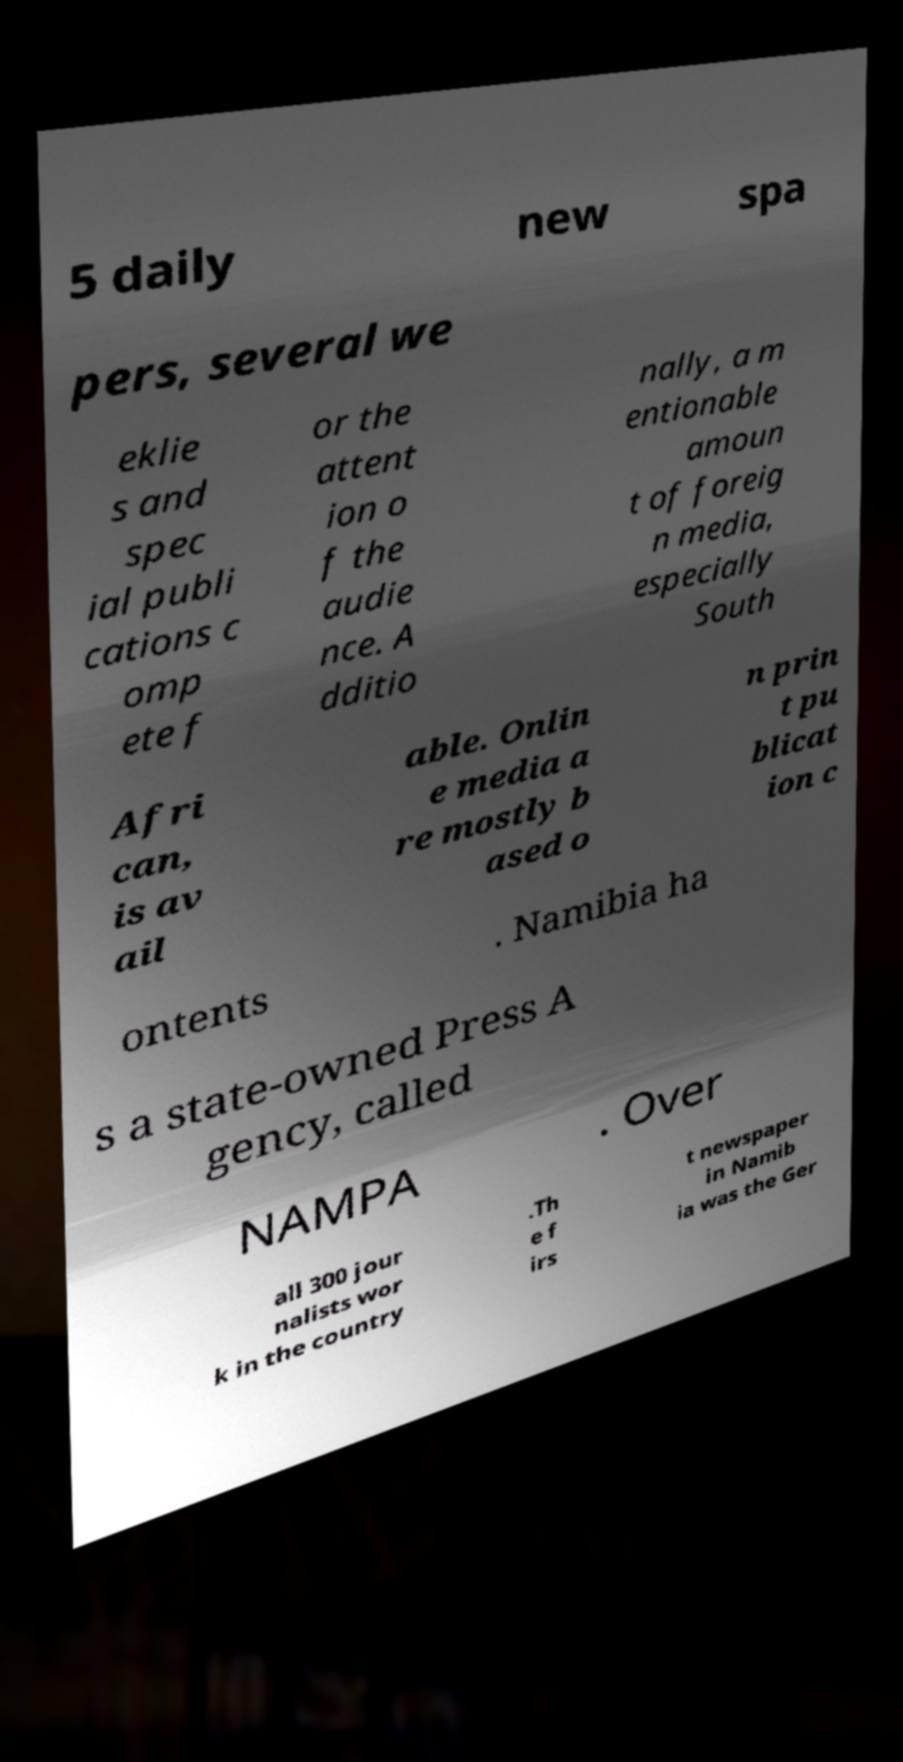What messages or text are displayed in this image? I need them in a readable, typed format. 5 daily new spa pers, several we eklie s and spec ial publi cations c omp ete f or the attent ion o f the audie nce. A dditio nally, a m entionable amoun t of foreig n media, especially South Afri can, is av ail able. Onlin e media a re mostly b ased o n prin t pu blicat ion c ontents . Namibia ha s a state-owned Press A gency, called NAMPA . Over all 300 jour nalists wor k in the country .Th e f irs t newspaper in Namib ia was the Ger 